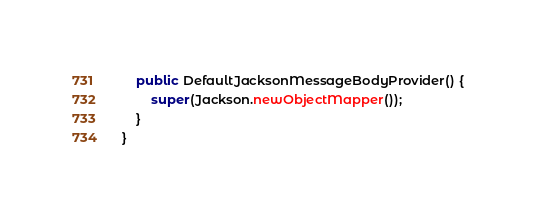Convert code to text. <code><loc_0><loc_0><loc_500><loc_500><_Java_>    public DefaultJacksonMessageBodyProvider() {
        super(Jackson.newObjectMapper());
    }
}
</code> 